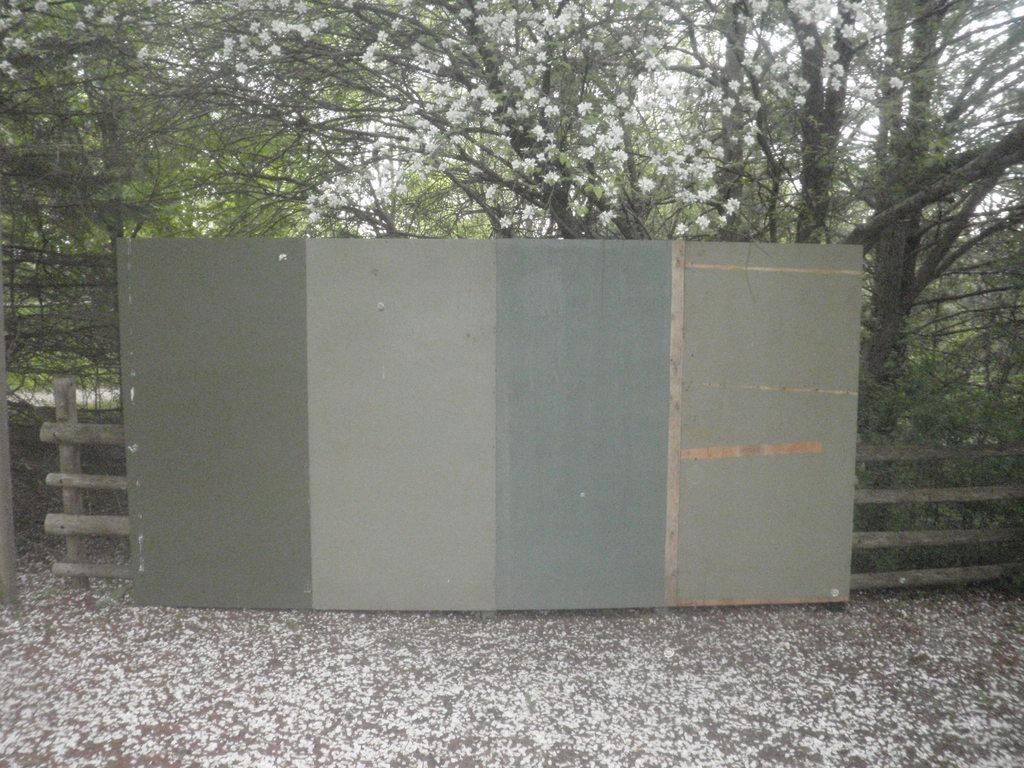What is the main object in the image? There is a board in the image. What other structures can be seen in the image? There is a fence in the image. What type of natural elements are visible in the background? There are trees in the background of the image. What is visible in the sky in the image? The sky is visible in the background of the image. Can you see a receipt on the board in the image? There is no receipt present on the board in the image. Is there a beetle crawling on the fence in the image? There is no beetle visible on the fence in the image. 